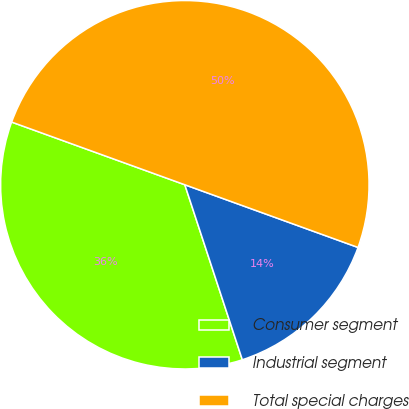Convert chart to OTSL. <chart><loc_0><loc_0><loc_500><loc_500><pie_chart><fcel>Consumer segment<fcel>Industrial segment<fcel>Total special charges<nl><fcel>35.58%<fcel>14.42%<fcel>50.0%<nl></chart> 